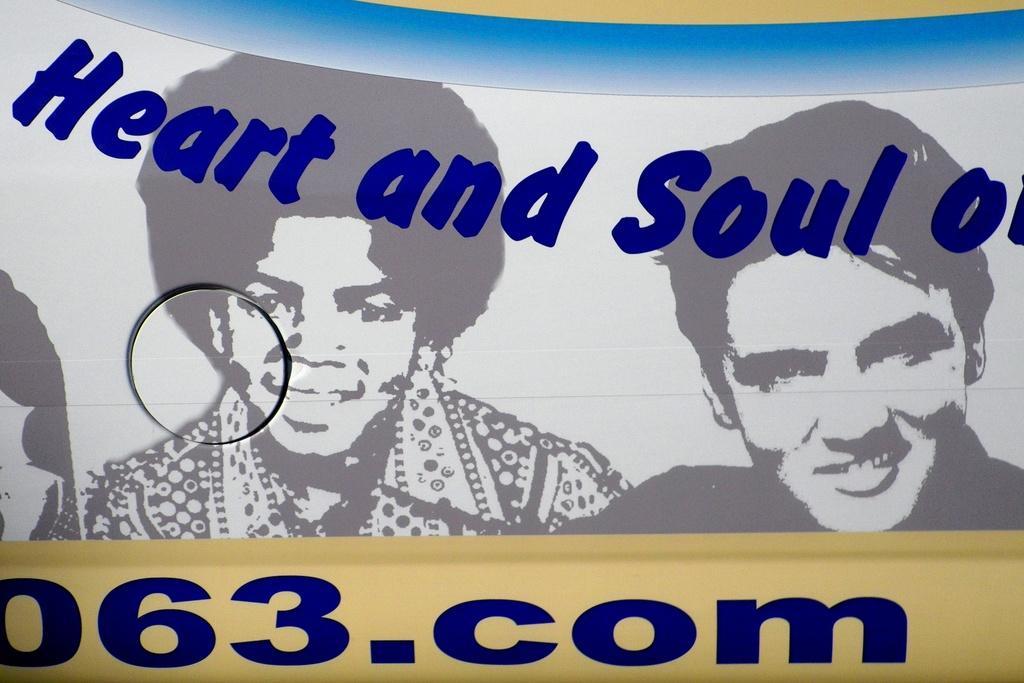In one or two sentences, can you explain what this image depicts? There is a poster having images of two persons who are smiling. And there are violet color texts on it. 